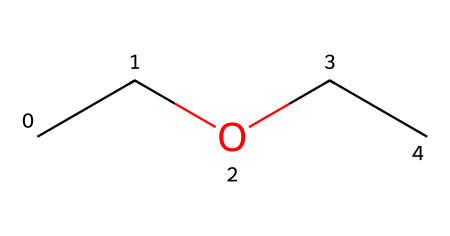What is the molecular formula of ethyl ether? Counting the number of carbon (C), hydrogen (H), and oxygen (O) atoms in the structure reveals that there are 4 carbon atoms, 10 hydrogen atoms, and 1 oxygen atom. Therefore, the molecular formula is C4H10O.
Answer: C4H10O How many carbon atoms are present in ethyl ether? From the SMILES representation, the string 'CC' indicates two consecutive carbon atoms. Each ‘C’ represents a carbon atom, and since there is another 'CC' in the structure corresponding to the ether link, we can deduce there are 4 carbon atoms total.
Answer: 4 What type of chemical bond connects the carbon and oxygen in ethyl ether? In the SMILES structure, the bonds between carbon and oxygen are single bonds, as indicated by the absence of any additional symbols like '=' or '#'. These symbols represent double and triple bonds, respectively.
Answer: single bond Is ethyl ether considered a flammable liquid? Ethyl ether has low flash point and is recognized for its high volatility and flammability, making it classified as a flammable liquid. Given its properties and history as an anesthetic agent, it exhibits a high potential for ignition.
Answer: yes What is the total number of hydrogen atoms in ethyl ether? By analyzing the structure from the SMILES representation, we see that the total number of hydrogen (H) atoms connected to the four carbon (C) atoms yields a total of 10 hydrogen atoms.
Answer: 10 What functional group defines ethyl ether? The ether functional group is represented by an oxygen atom (O) bonded to two carbon chains, which is characteristic of ethers. In the SMILES, the presence of an 'O' between two 'CC' notations indicates the ether functional group.
Answer: ether 